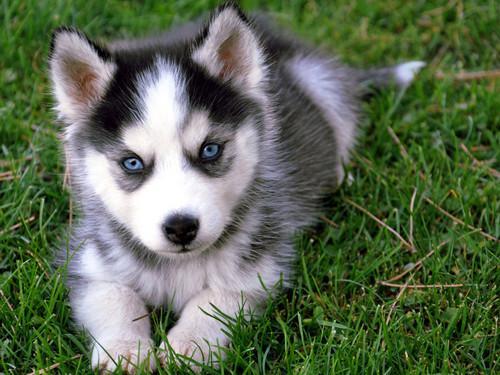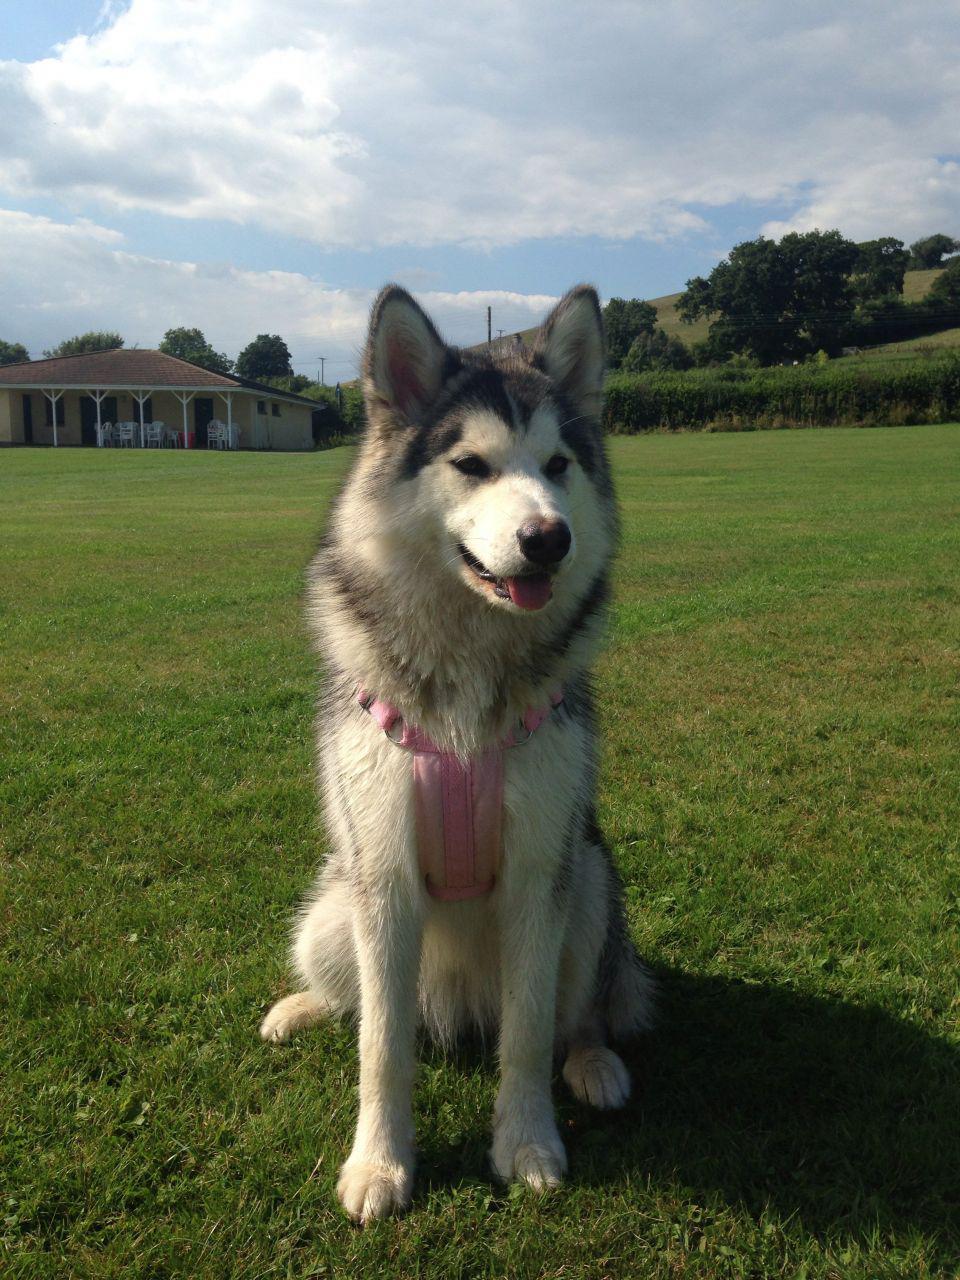The first image is the image on the left, the second image is the image on the right. For the images shown, is this caption "A dog is standing." true? Answer yes or no. No. The first image is the image on the left, the second image is the image on the right. Examine the images to the left and right. Is the description "There is a single puppy husky with blue eyes and white, black fur laying in the grass." accurate? Answer yes or no. Yes. 